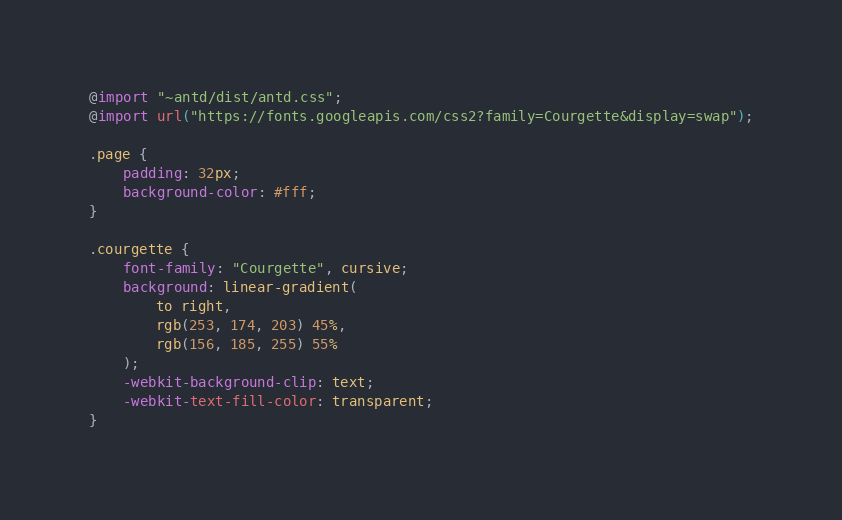<code> <loc_0><loc_0><loc_500><loc_500><_CSS_>@import "~antd/dist/antd.css";
@import url("https://fonts.googleapis.com/css2?family=Courgette&display=swap");

.page {
    padding: 32px;
    background-color: #fff;
}

.courgette {
    font-family: "Courgette", cursive;
    background: linear-gradient(
        to right,
        rgb(253, 174, 203) 45%,
        rgb(156, 185, 255) 55%
    );
    -webkit-background-clip: text;
    -webkit-text-fill-color: transparent;
}
</code> 